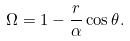Convert formula to latex. <formula><loc_0><loc_0><loc_500><loc_500>\Omega = 1 - \frac { r } { \alpha } \cos \theta .</formula> 